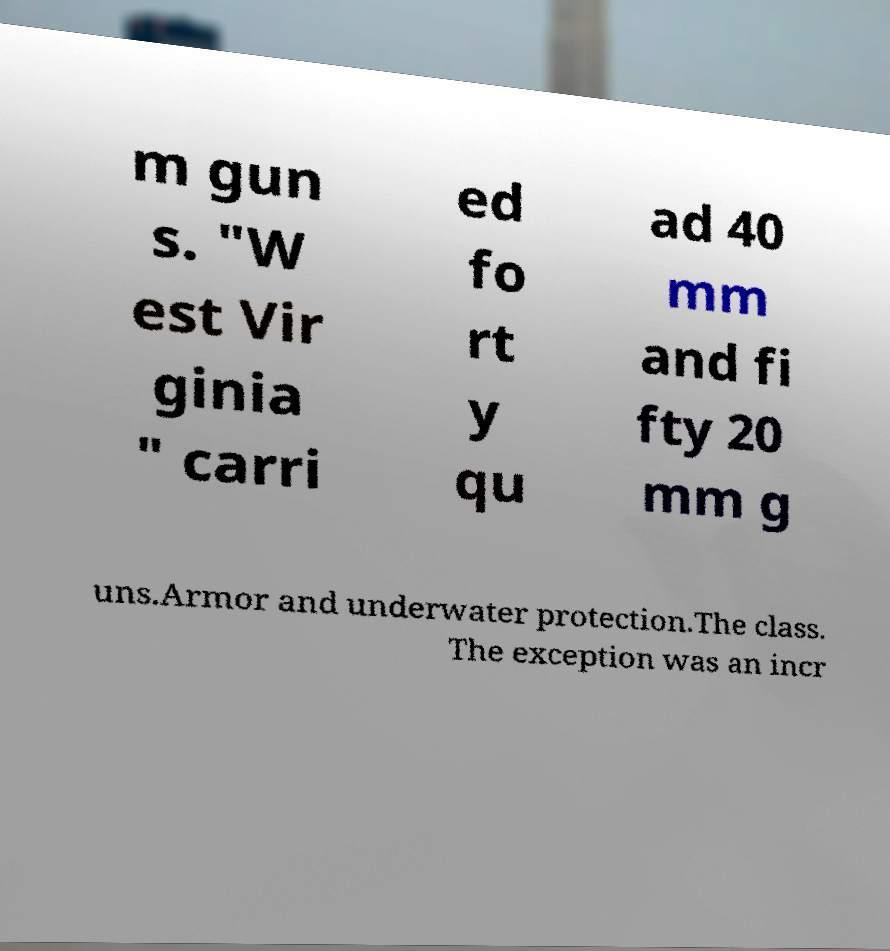Could you extract and type out the text from this image? m gun s. "W est Vir ginia " carri ed fo rt y qu ad 40 mm and fi fty 20 mm g uns.Armor and underwater protection.The class. The exception was an incr 